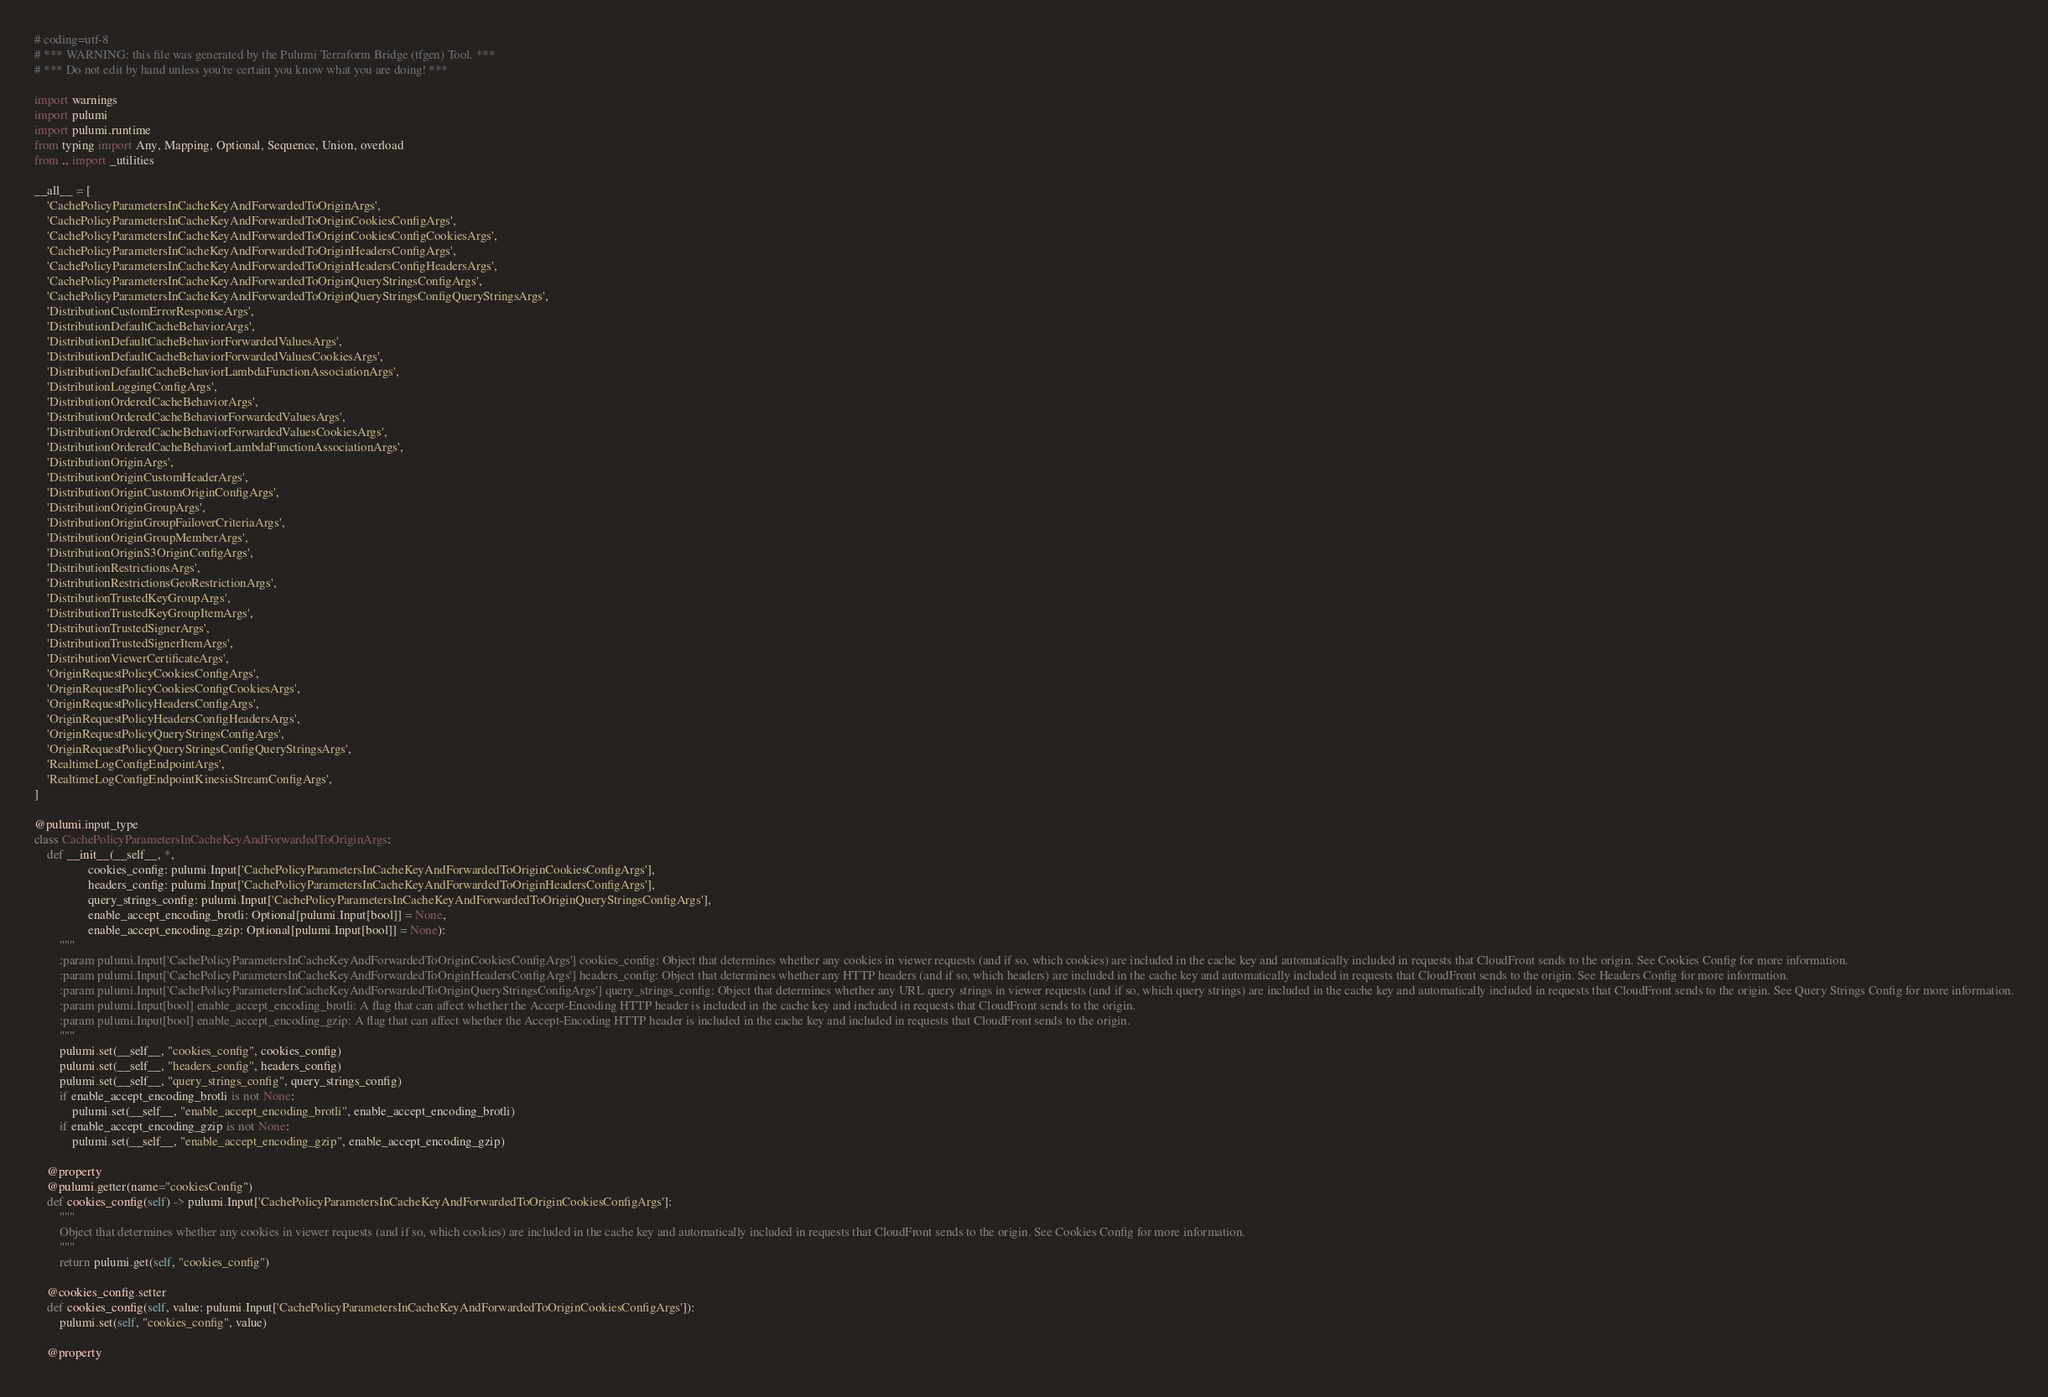Convert code to text. <code><loc_0><loc_0><loc_500><loc_500><_Python_># coding=utf-8
# *** WARNING: this file was generated by the Pulumi Terraform Bridge (tfgen) Tool. ***
# *** Do not edit by hand unless you're certain you know what you are doing! ***

import warnings
import pulumi
import pulumi.runtime
from typing import Any, Mapping, Optional, Sequence, Union, overload
from .. import _utilities

__all__ = [
    'CachePolicyParametersInCacheKeyAndForwardedToOriginArgs',
    'CachePolicyParametersInCacheKeyAndForwardedToOriginCookiesConfigArgs',
    'CachePolicyParametersInCacheKeyAndForwardedToOriginCookiesConfigCookiesArgs',
    'CachePolicyParametersInCacheKeyAndForwardedToOriginHeadersConfigArgs',
    'CachePolicyParametersInCacheKeyAndForwardedToOriginHeadersConfigHeadersArgs',
    'CachePolicyParametersInCacheKeyAndForwardedToOriginQueryStringsConfigArgs',
    'CachePolicyParametersInCacheKeyAndForwardedToOriginQueryStringsConfigQueryStringsArgs',
    'DistributionCustomErrorResponseArgs',
    'DistributionDefaultCacheBehaviorArgs',
    'DistributionDefaultCacheBehaviorForwardedValuesArgs',
    'DistributionDefaultCacheBehaviorForwardedValuesCookiesArgs',
    'DistributionDefaultCacheBehaviorLambdaFunctionAssociationArgs',
    'DistributionLoggingConfigArgs',
    'DistributionOrderedCacheBehaviorArgs',
    'DistributionOrderedCacheBehaviorForwardedValuesArgs',
    'DistributionOrderedCacheBehaviorForwardedValuesCookiesArgs',
    'DistributionOrderedCacheBehaviorLambdaFunctionAssociationArgs',
    'DistributionOriginArgs',
    'DistributionOriginCustomHeaderArgs',
    'DistributionOriginCustomOriginConfigArgs',
    'DistributionOriginGroupArgs',
    'DistributionOriginGroupFailoverCriteriaArgs',
    'DistributionOriginGroupMemberArgs',
    'DistributionOriginS3OriginConfigArgs',
    'DistributionRestrictionsArgs',
    'DistributionRestrictionsGeoRestrictionArgs',
    'DistributionTrustedKeyGroupArgs',
    'DistributionTrustedKeyGroupItemArgs',
    'DistributionTrustedSignerArgs',
    'DistributionTrustedSignerItemArgs',
    'DistributionViewerCertificateArgs',
    'OriginRequestPolicyCookiesConfigArgs',
    'OriginRequestPolicyCookiesConfigCookiesArgs',
    'OriginRequestPolicyHeadersConfigArgs',
    'OriginRequestPolicyHeadersConfigHeadersArgs',
    'OriginRequestPolicyQueryStringsConfigArgs',
    'OriginRequestPolicyQueryStringsConfigQueryStringsArgs',
    'RealtimeLogConfigEndpointArgs',
    'RealtimeLogConfigEndpointKinesisStreamConfigArgs',
]

@pulumi.input_type
class CachePolicyParametersInCacheKeyAndForwardedToOriginArgs:
    def __init__(__self__, *,
                 cookies_config: pulumi.Input['CachePolicyParametersInCacheKeyAndForwardedToOriginCookiesConfigArgs'],
                 headers_config: pulumi.Input['CachePolicyParametersInCacheKeyAndForwardedToOriginHeadersConfigArgs'],
                 query_strings_config: pulumi.Input['CachePolicyParametersInCacheKeyAndForwardedToOriginQueryStringsConfigArgs'],
                 enable_accept_encoding_brotli: Optional[pulumi.Input[bool]] = None,
                 enable_accept_encoding_gzip: Optional[pulumi.Input[bool]] = None):
        """
        :param pulumi.Input['CachePolicyParametersInCacheKeyAndForwardedToOriginCookiesConfigArgs'] cookies_config: Object that determines whether any cookies in viewer requests (and if so, which cookies) are included in the cache key and automatically included in requests that CloudFront sends to the origin. See Cookies Config for more information.
        :param pulumi.Input['CachePolicyParametersInCacheKeyAndForwardedToOriginHeadersConfigArgs'] headers_config: Object that determines whether any HTTP headers (and if so, which headers) are included in the cache key and automatically included in requests that CloudFront sends to the origin. See Headers Config for more information.
        :param pulumi.Input['CachePolicyParametersInCacheKeyAndForwardedToOriginQueryStringsConfigArgs'] query_strings_config: Object that determines whether any URL query strings in viewer requests (and if so, which query strings) are included in the cache key and automatically included in requests that CloudFront sends to the origin. See Query Strings Config for more information.
        :param pulumi.Input[bool] enable_accept_encoding_brotli: A flag that can affect whether the Accept-Encoding HTTP header is included in the cache key and included in requests that CloudFront sends to the origin.
        :param pulumi.Input[bool] enable_accept_encoding_gzip: A flag that can affect whether the Accept-Encoding HTTP header is included in the cache key and included in requests that CloudFront sends to the origin.
        """
        pulumi.set(__self__, "cookies_config", cookies_config)
        pulumi.set(__self__, "headers_config", headers_config)
        pulumi.set(__self__, "query_strings_config", query_strings_config)
        if enable_accept_encoding_brotli is not None:
            pulumi.set(__self__, "enable_accept_encoding_brotli", enable_accept_encoding_brotli)
        if enable_accept_encoding_gzip is not None:
            pulumi.set(__self__, "enable_accept_encoding_gzip", enable_accept_encoding_gzip)

    @property
    @pulumi.getter(name="cookiesConfig")
    def cookies_config(self) -> pulumi.Input['CachePolicyParametersInCacheKeyAndForwardedToOriginCookiesConfigArgs']:
        """
        Object that determines whether any cookies in viewer requests (and if so, which cookies) are included in the cache key and automatically included in requests that CloudFront sends to the origin. See Cookies Config for more information.
        """
        return pulumi.get(self, "cookies_config")

    @cookies_config.setter
    def cookies_config(self, value: pulumi.Input['CachePolicyParametersInCacheKeyAndForwardedToOriginCookiesConfigArgs']):
        pulumi.set(self, "cookies_config", value)

    @property</code> 